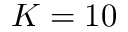Convert formula to latex. <formula><loc_0><loc_0><loc_500><loc_500>K = 1 0</formula> 